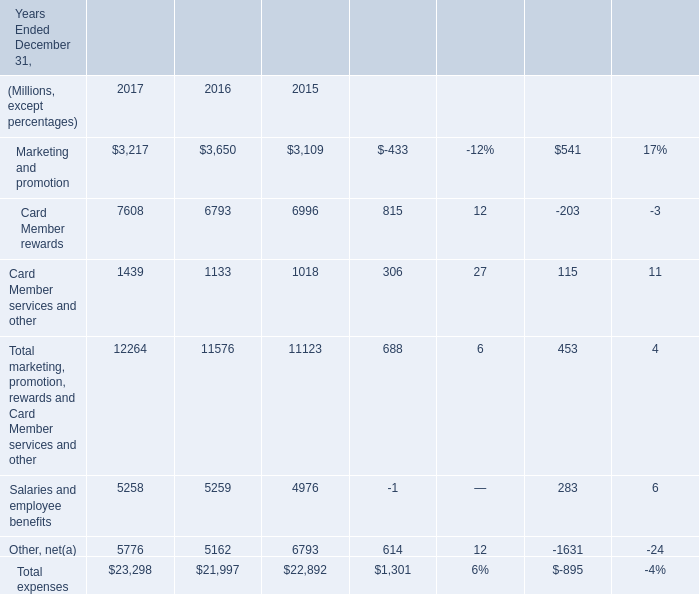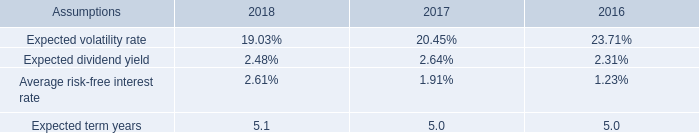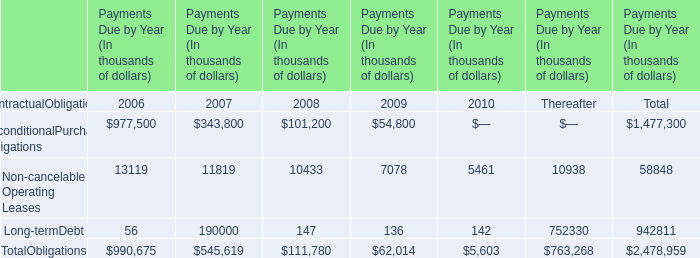What's the current increasing rate of Other, net ? 
Computations: ((5776 - 5162) / 5162)
Answer: 0.11895. 